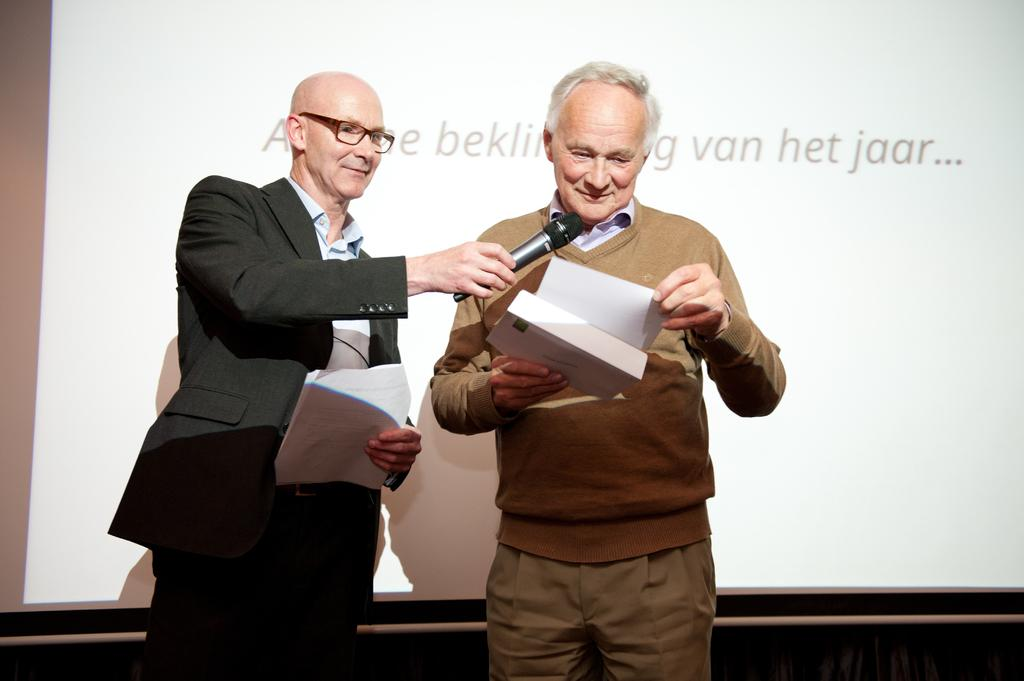How many people are in the image? There are two men in the image. What are the men holding in their hands? The men are holding papers in their hands. Can you describe the appearance of one of the men? One of the men is wearing spectacles. What object is being held by one of the men? There is a microphone in the hand of one of the men. What can be seen behind the two men? There is a screen behind the two men. What type of egg is being used as a horn in the image? There is no egg or horn present in the image. How is the connection between the two men established in the image? The connection between the two men is not explicitly shown in the image, but they are both holding papers and standing close to each other, which might suggest they are working together or discussing something. 